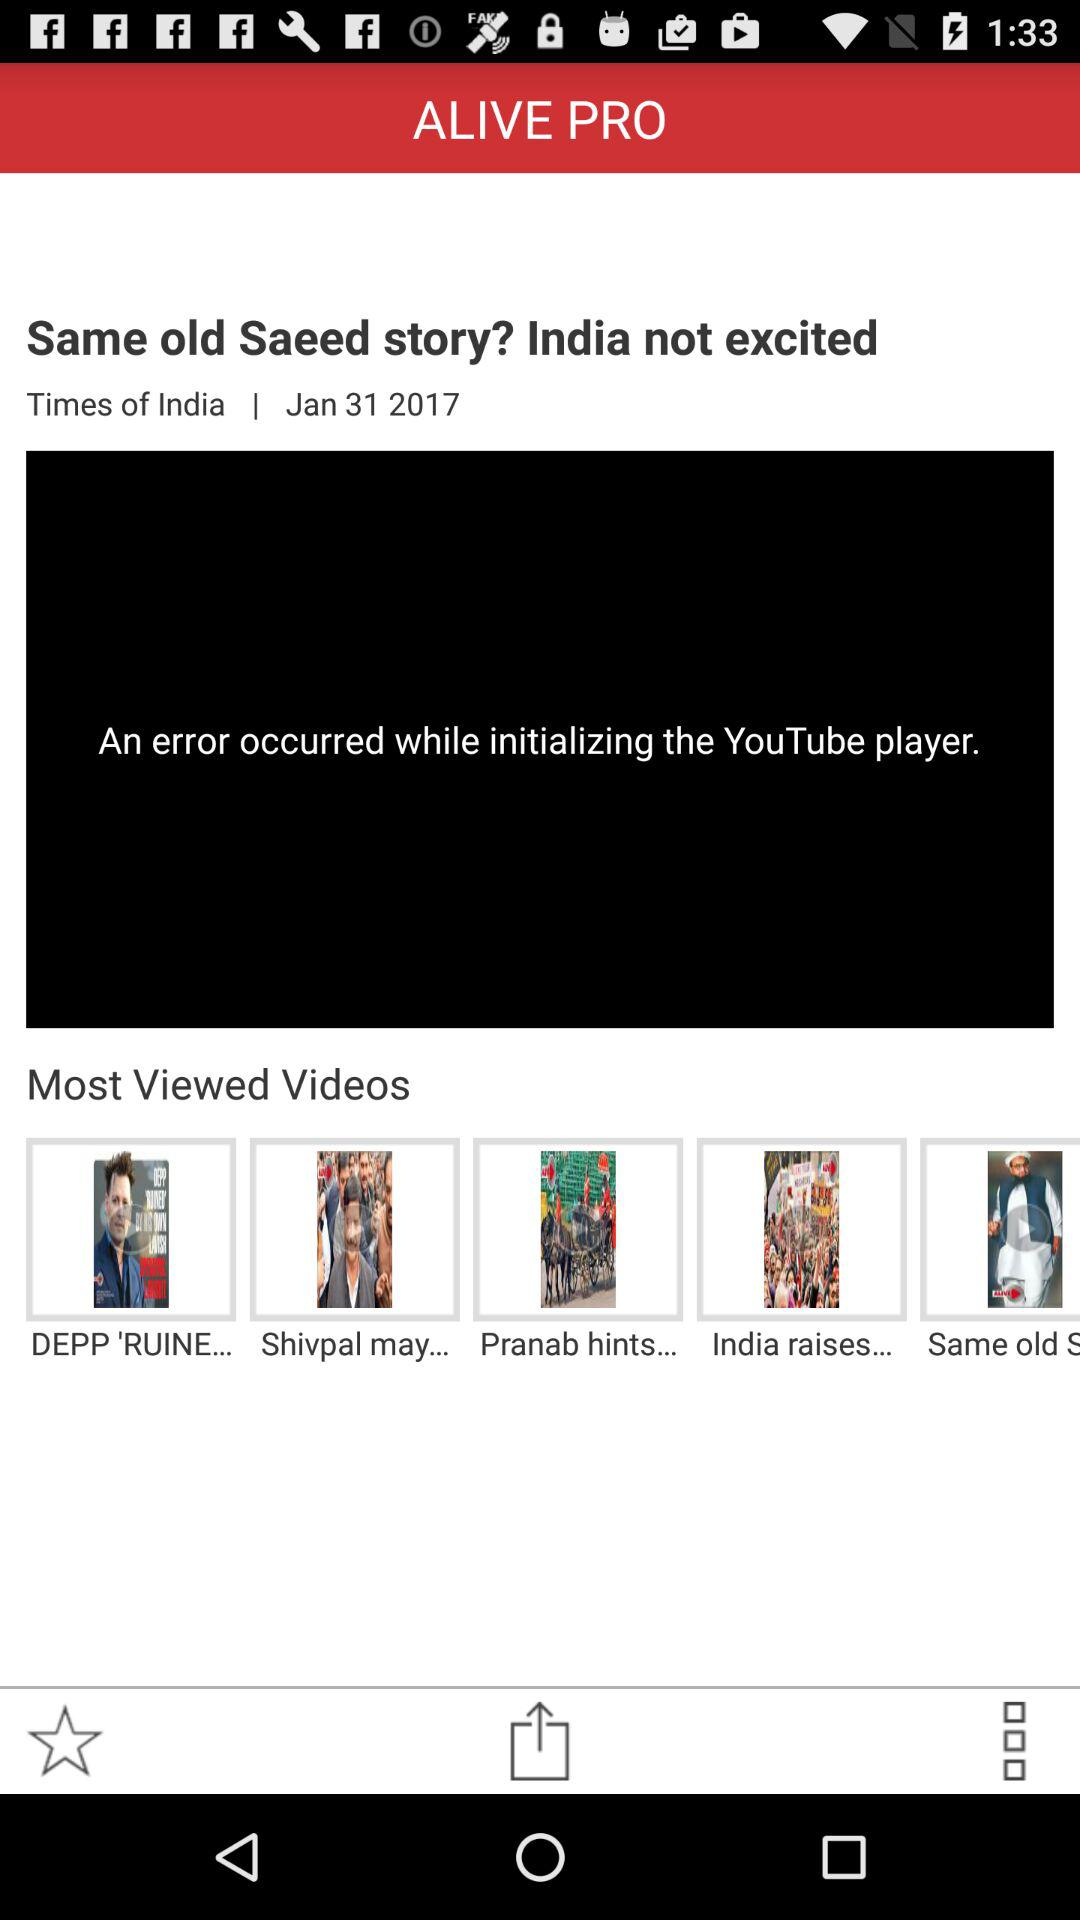What is the news date? The news date is January 31, 2017. 